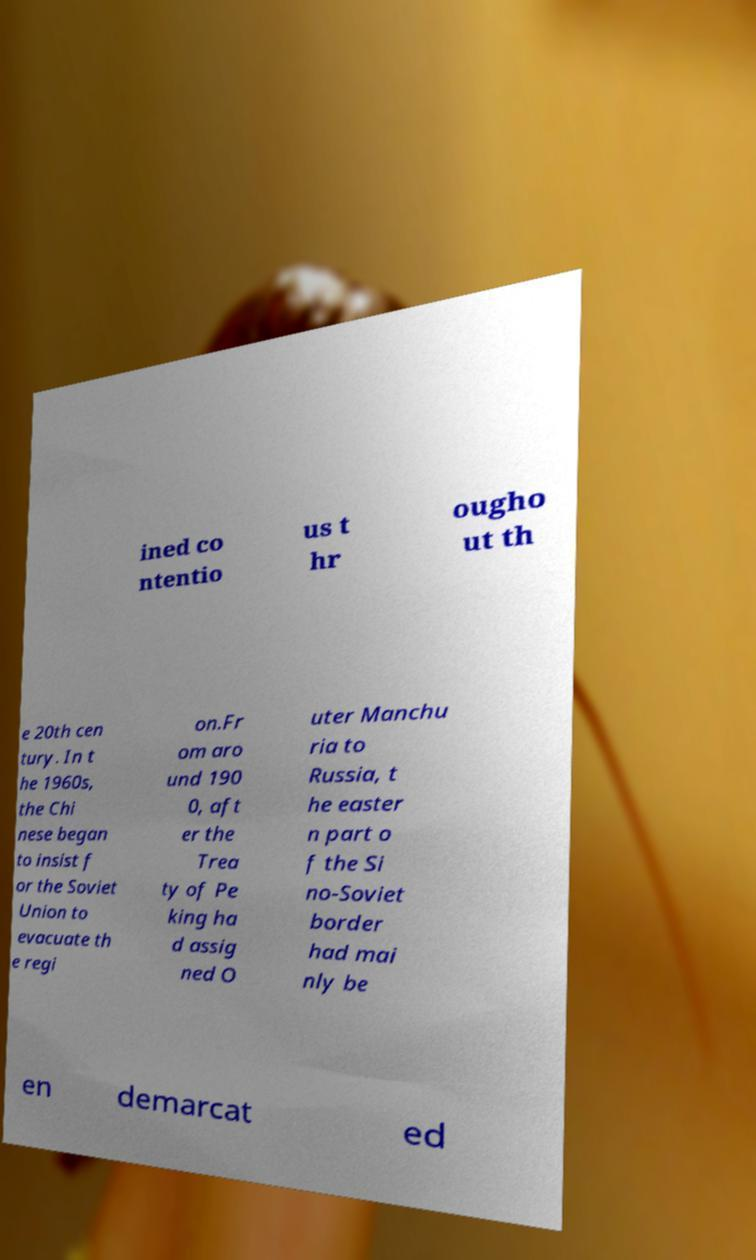Can you read and provide the text displayed in the image?This photo seems to have some interesting text. Can you extract and type it out for me? ined co ntentio us t hr ougho ut th e 20th cen tury. In t he 1960s, the Chi nese began to insist f or the Soviet Union to evacuate th e regi on.Fr om aro und 190 0, aft er the Trea ty of Pe king ha d assig ned O uter Manchu ria to Russia, t he easter n part o f the Si no-Soviet border had mai nly be en demarcat ed 